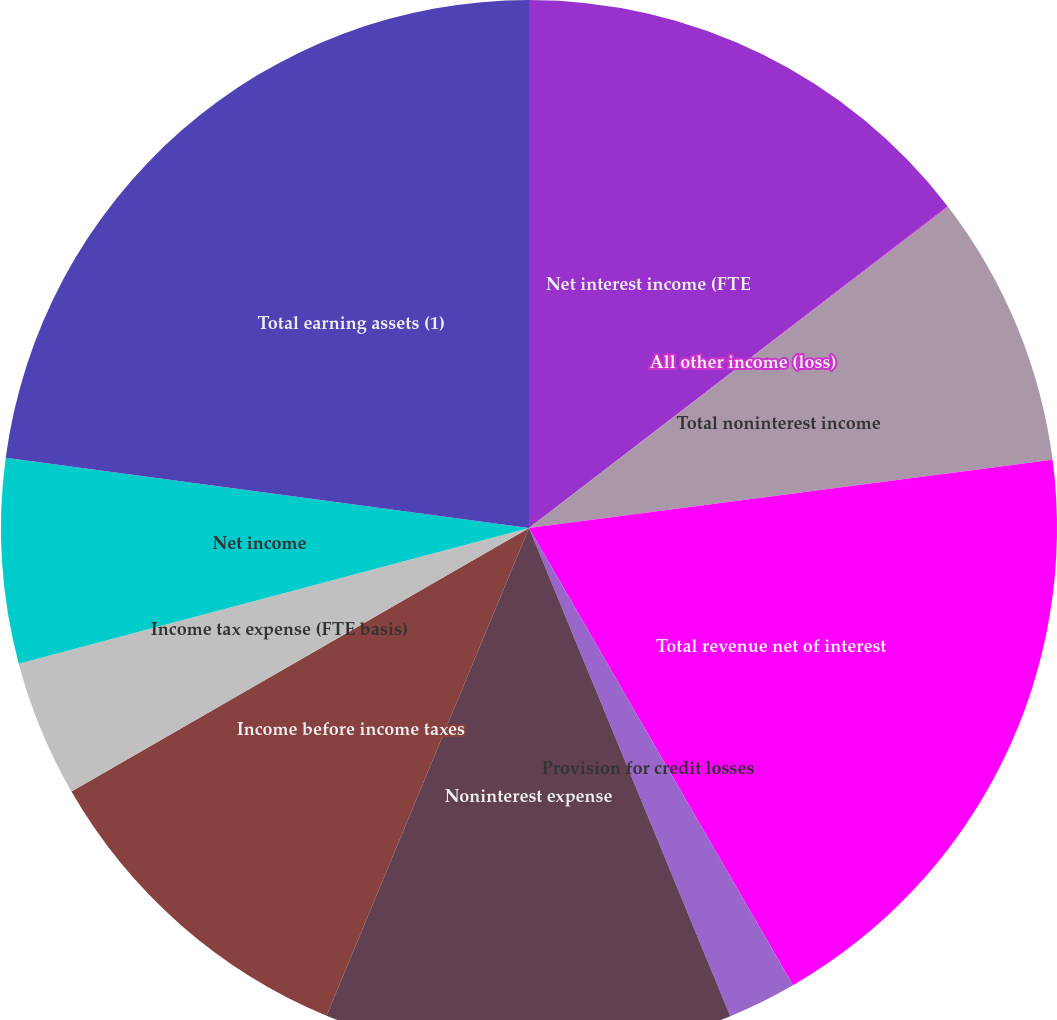<chart> <loc_0><loc_0><loc_500><loc_500><pie_chart><fcel>Net interest income (FTE<fcel>All other income (loss)<fcel>Total noninterest income<fcel>Total revenue net of interest<fcel>Provision for credit losses<fcel>Noninterest expense<fcel>Income before income taxes<fcel>Income tax expense (FTE basis)<fcel>Net income<fcel>Total earning assets (1)<nl><fcel>14.57%<fcel>0.03%<fcel>8.34%<fcel>18.73%<fcel>2.11%<fcel>12.49%<fcel>10.42%<fcel>4.18%<fcel>6.26%<fcel>22.88%<nl></chart> 